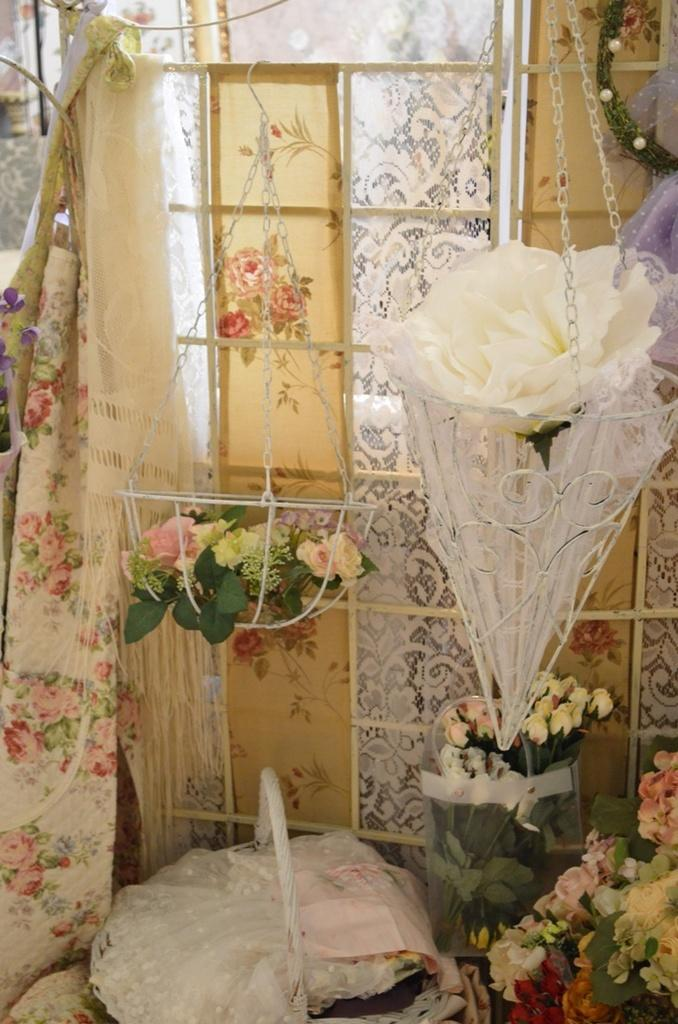What can be found in the baskets in the image? There are flowers in the baskets in the image. What else is present in the image besides the flowers in the baskets? There are other things in the image. Can you describe what is on the left side of the image? There are clothes on the left side of the image. What type of government is depicted in the image? There is no depiction of a government in the image; it features flowers in baskets, other items, and clothes on the left side. Is there any smoke visible in the image? There is no smoke present in the image. 